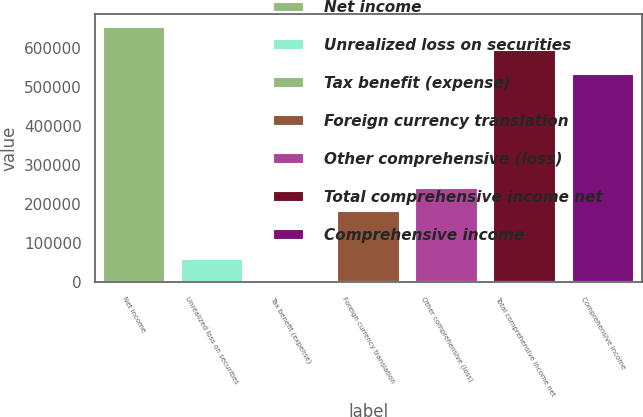Convert chart. <chart><loc_0><loc_0><loc_500><loc_500><bar_chart><fcel>Net income<fcel>Unrealized loss on securities<fcel>Tax benefit (expense)<fcel>Foreign currency translation<fcel>Other comprehensive (loss)<fcel>Total comprehensive income net<fcel>Comprehensive income<nl><fcel>655056<fcel>60676.9<fcel>149<fcel>181733<fcel>242261<fcel>594528<fcel>534000<nl></chart> 